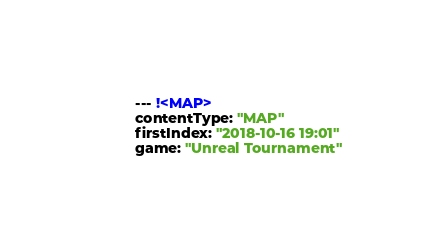Convert code to text. <code><loc_0><loc_0><loc_500><loc_500><_YAML_>--- !<MAP>
contentType: "MAP"
firstIndex: "2018-10-16 19:01"
game: "Unreal Tournament"</code> 